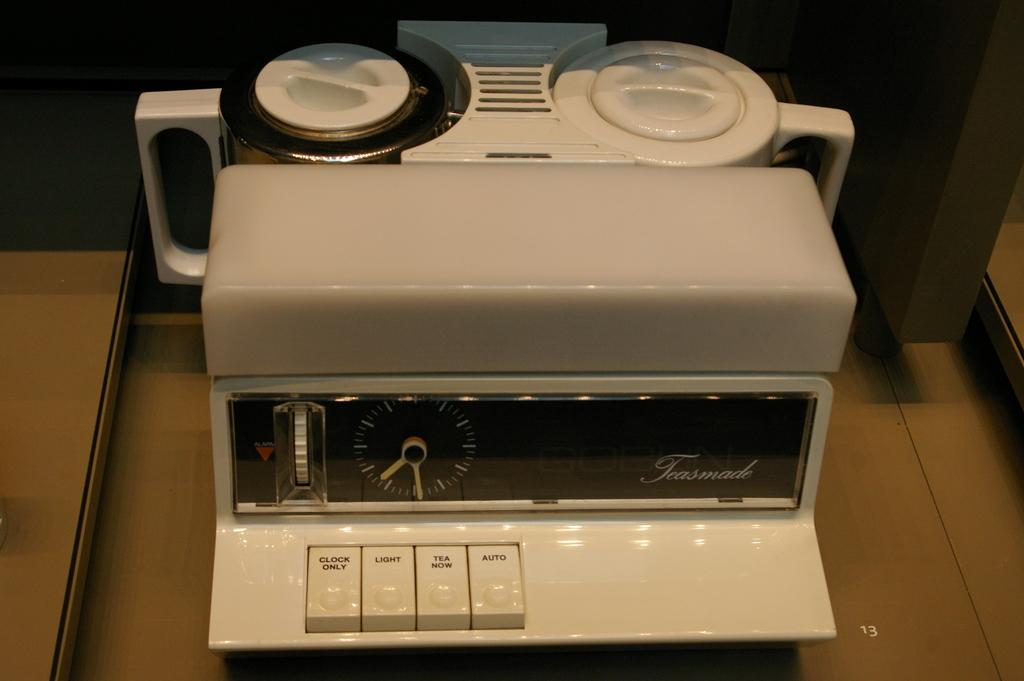<image>
Summarize the visual content of the image. A machine called a Teasmade is on a counter 